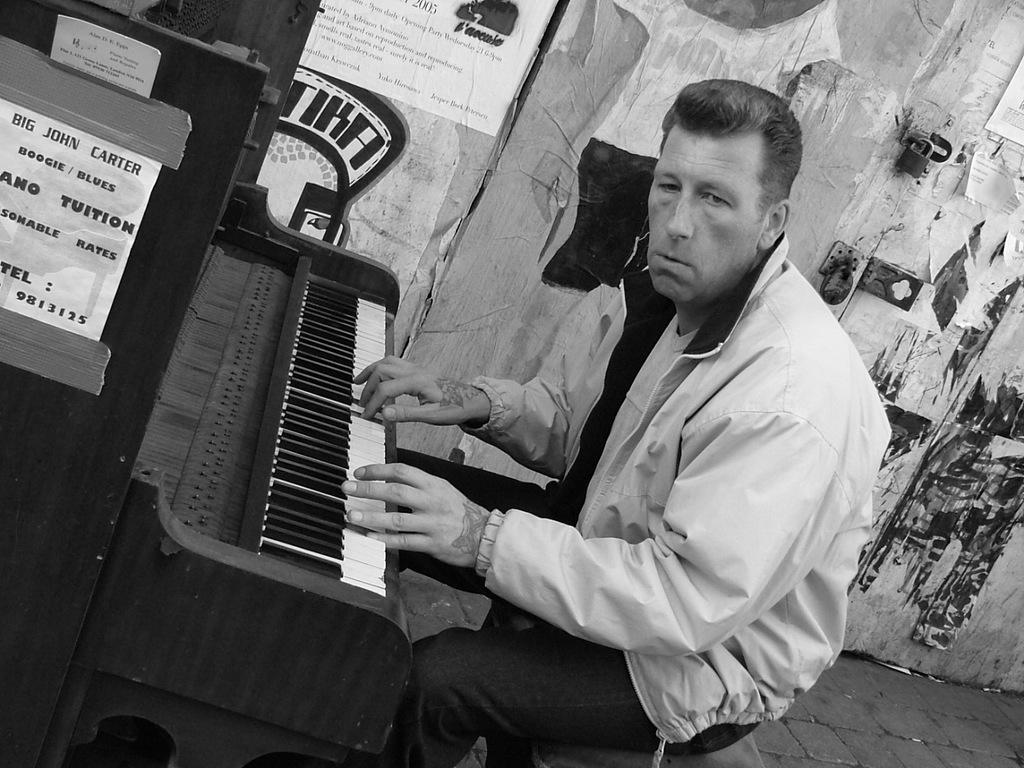Who is in the image? There is a man in the image. What is the man doing in the image? The man is sitting and playing a piano. What can be seen in the background of the image? There is a wall with stickers and a door in the background. Can you describe the lock in the background? There is a lock in the background, but its specific details cannot be determined from the image. What type of pen is the snake using to write on the train in the image? There is no snake, pen, or train present in the image. 